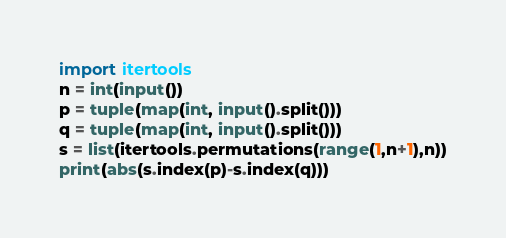Convert code to text. <code><loc_0><loc_0><loc_500><loc_500><_Python_>import itertools
n = int(input())
p = tuple(map(int, input().split()))
q = tuple(map(int, input().split()))
s = list(itertools.permutations(range(1,n+1),n))
print(abs(s.index(p)-s.index(q)))</code> 